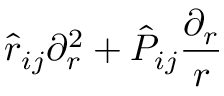<formula> <loc_0><loc_0><loc_500><loc_500>\hat { r } _ { i j } \partial _ { r } ^ { 2 } + \hat { P } _ { i j } \frac { \partial _ { r } } { r }</formula> 